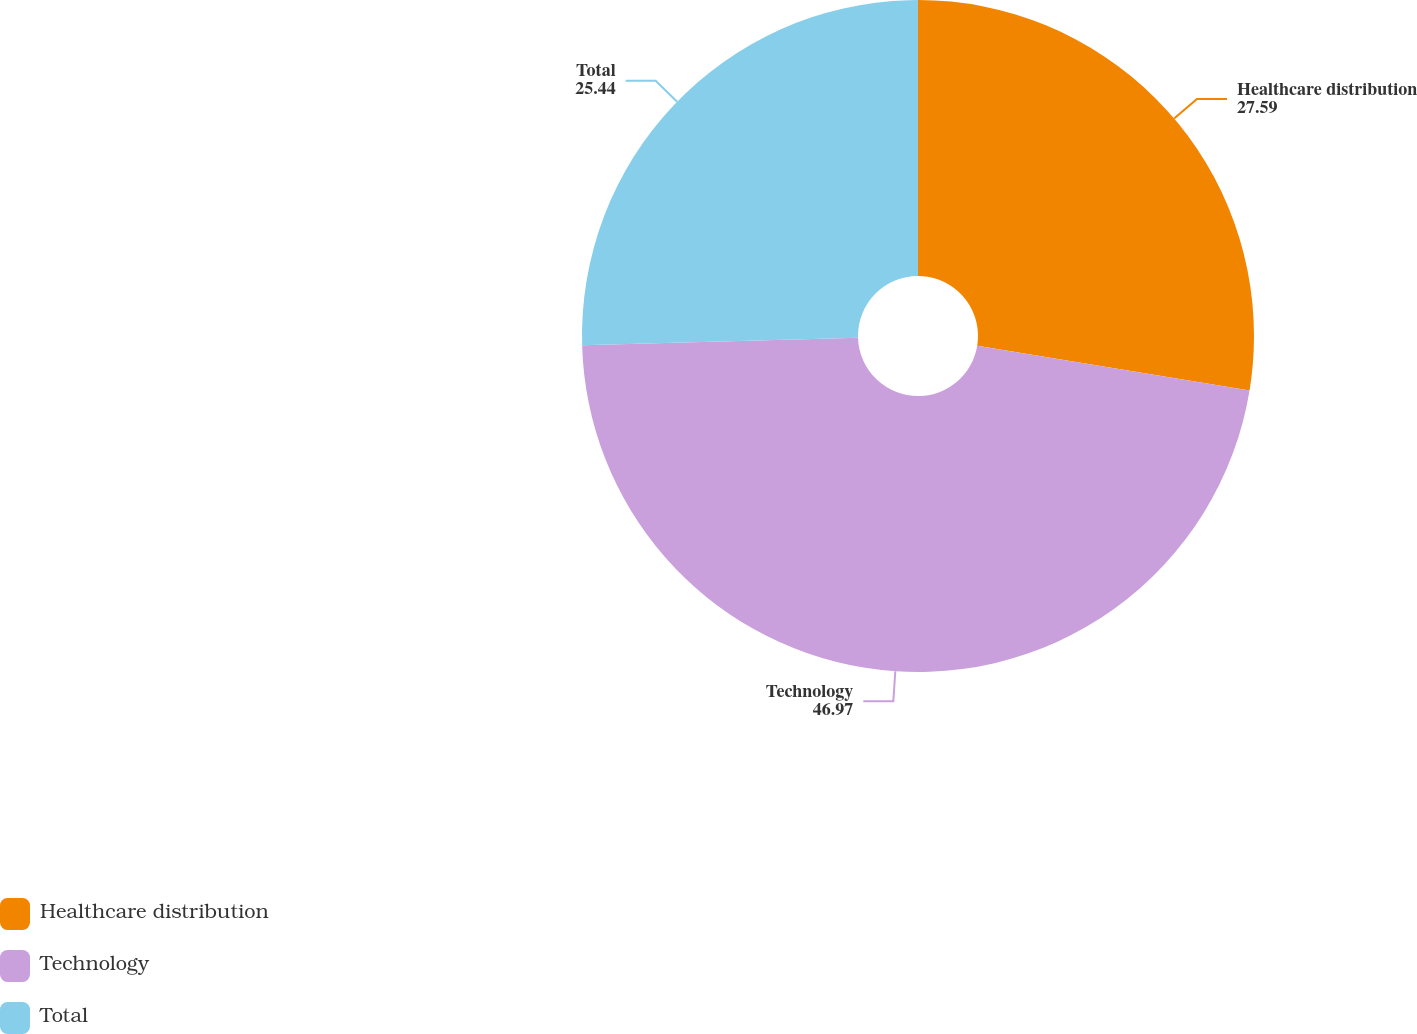<chart> <loc_0><loc_0><loc_500><loc_500><pie_chart><fcel>Healthcare distribution<fcel>Technology<fcel>Total<nl><fcel>27.59%<fcel>46.97%<fcel>25.44%<nl></chart> 